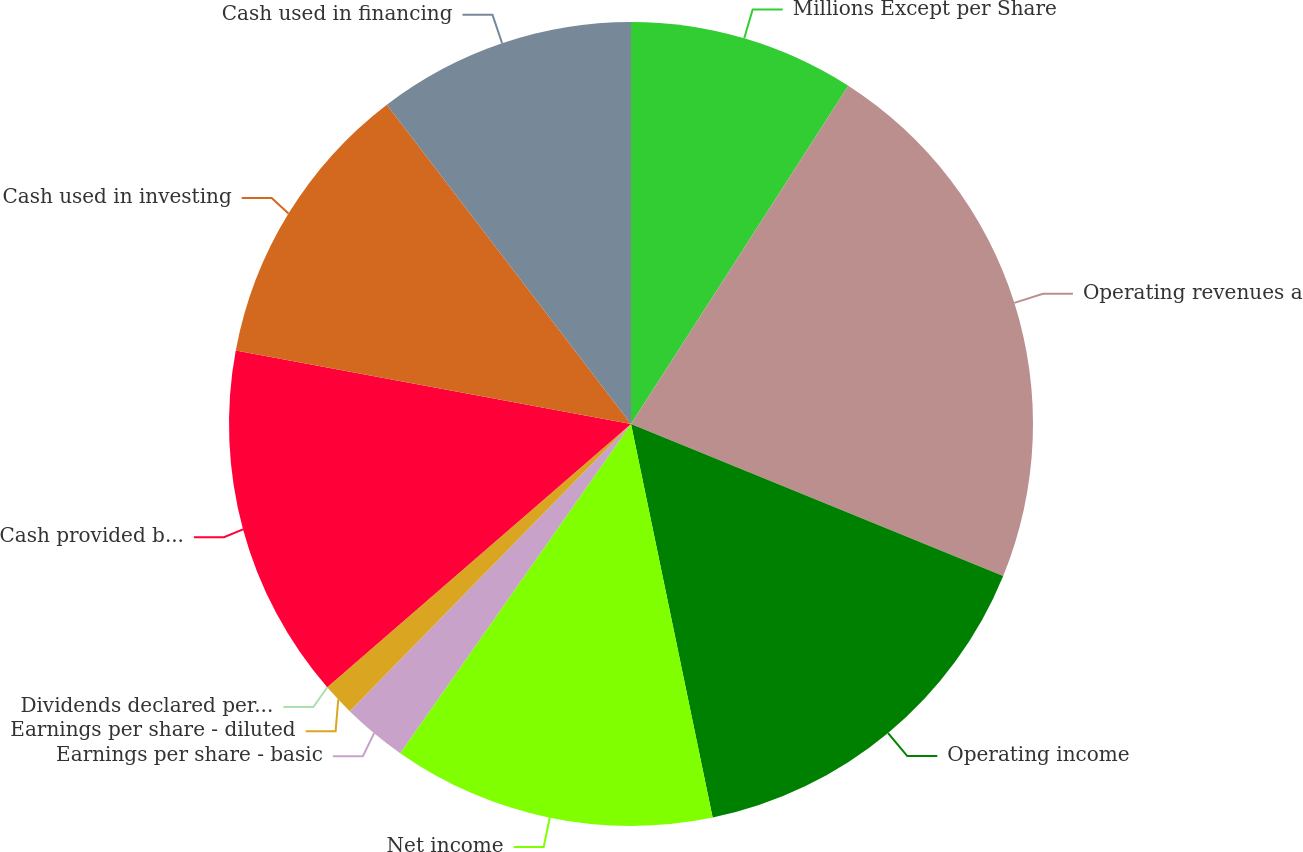Convert chart to OTSL. <chart><loc_0><loc_0><loc_500><loc_500><pie_chart><fcel>Millions Except per Share<fcel>Operating revenues a<fcel>Operating income<fcel>Net income<fcel>Earnings per share - basic<fcel>Earnings per share - diluted<fcel>Dividends declared per share<fcel>Cash provided by operating<fcel>Cash used in investing<fcel>Cash used in financing<nl><fcel>9.09%<fcel>22.08%<fcel>15.58%<fcel>12.99%<fcel>2.6%<fcel>1.3%<fcel>0.0%<fcel>14.29%<fcel>11.69%<fcel>10.39%<nl></chart> 